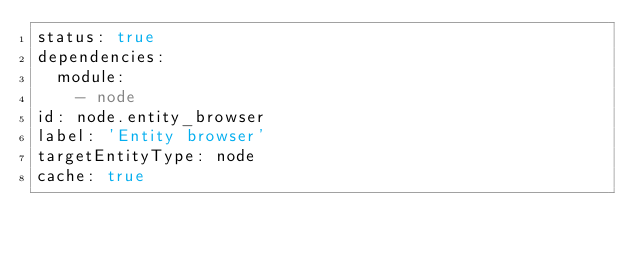<code> <loc_0><loc_0><loc_500><loc_500><_YAML_>status: true
dependencies:
  module:
    - node
id: node.entity_browser
label: 'Entity browser'
targetEntityType: node
cache: true
</code> 